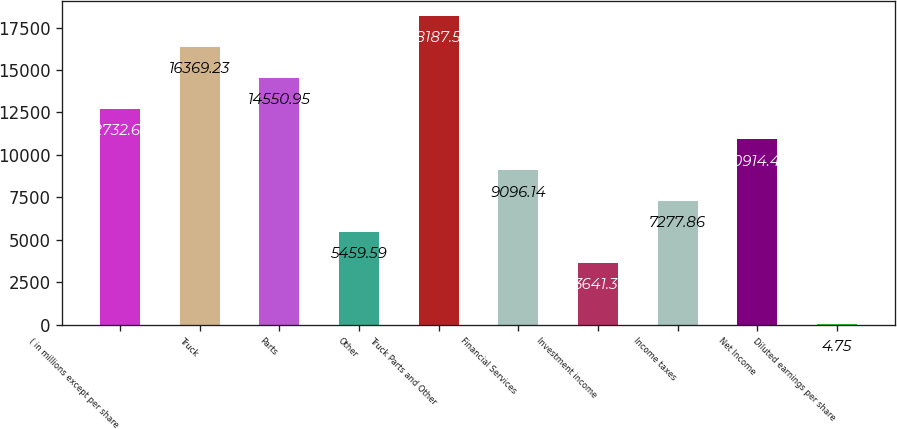Convert chart. <chart><loc_0><loc_0><loc_500><loc_500><bar_chart><fcel>( in millions except per share<fcel>Truck<fcel>Parts<fcel>Other<fcel>Truck Parts and Other<fcel>Financial Services<fcel>Investment income<fcel>Income taxes<fcel>Net Income<fcel>Diluted earnings per share<nl><fcel>12732.7<fcel>16369.2<fcel>14551<fcel>5459.59<fcel>18187.5<fcel>9096.14<fcel>3641.31<fcel>7277.86<fcel>10914.4<fcel>4.75<nl></chart> 